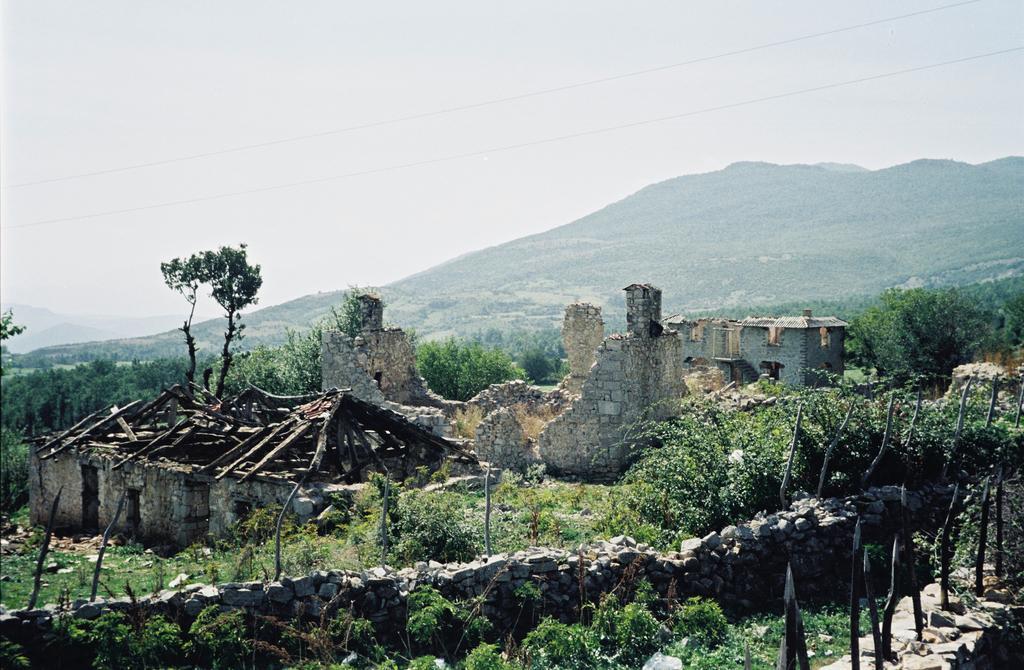In one or two sentences, can you explain what this image depicts? In this image I can a demolished house and a wall in front of the house. Around the house we can see some plants and trees and behind the house there is a hill station. On top of the image we can see two electric wires. 